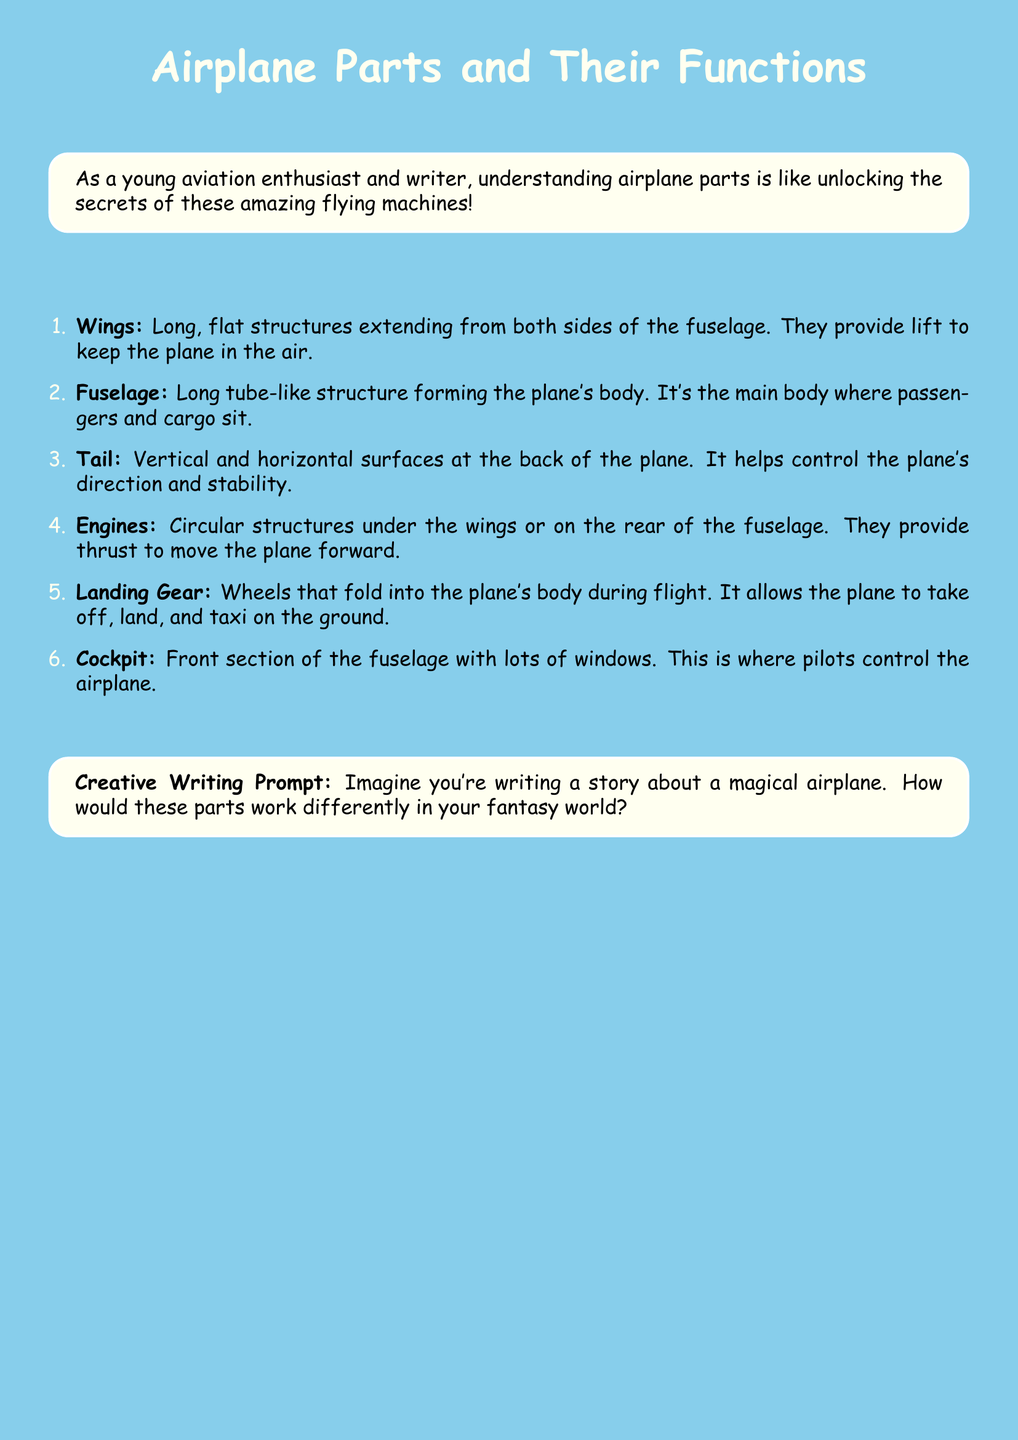What is the title of the document? The title is explicitly stated at the beginning of the document.
Answer: Airplane Parts and Their Functions How many airplane parts are listed in the document? The document enumerates different parts, which can be counted.
Answer: 6 What is the function of the wings? The function of the wings is described in the context of providing lift.
Answer: Provide lift to keep the plane in the air Which part helps control the plane’s direction and stability? The tail's role is specifically highlighted in the document regarding control and stability.
Answer: Tail What structure allows the plane to take off, land, and taxi? The document specifies a particular part associated with these movements.
Answer: Landing Gear Where do pilots control the airplane? The document mentions a specific section where pilots operate the plane.
Answer: Cockpit What is the creative writing prompt about? The prompt encourages imaginative writing related to the airplane parts.
Answer: A magical airplane What do engines provide to the airplane? The function of the engines is linked to the movement of the airplane.
Answer: Thrust to move the plane forward What shape is the fuselage? The description of the fuselage highlights its form.
Answer: Long tube-like structure 